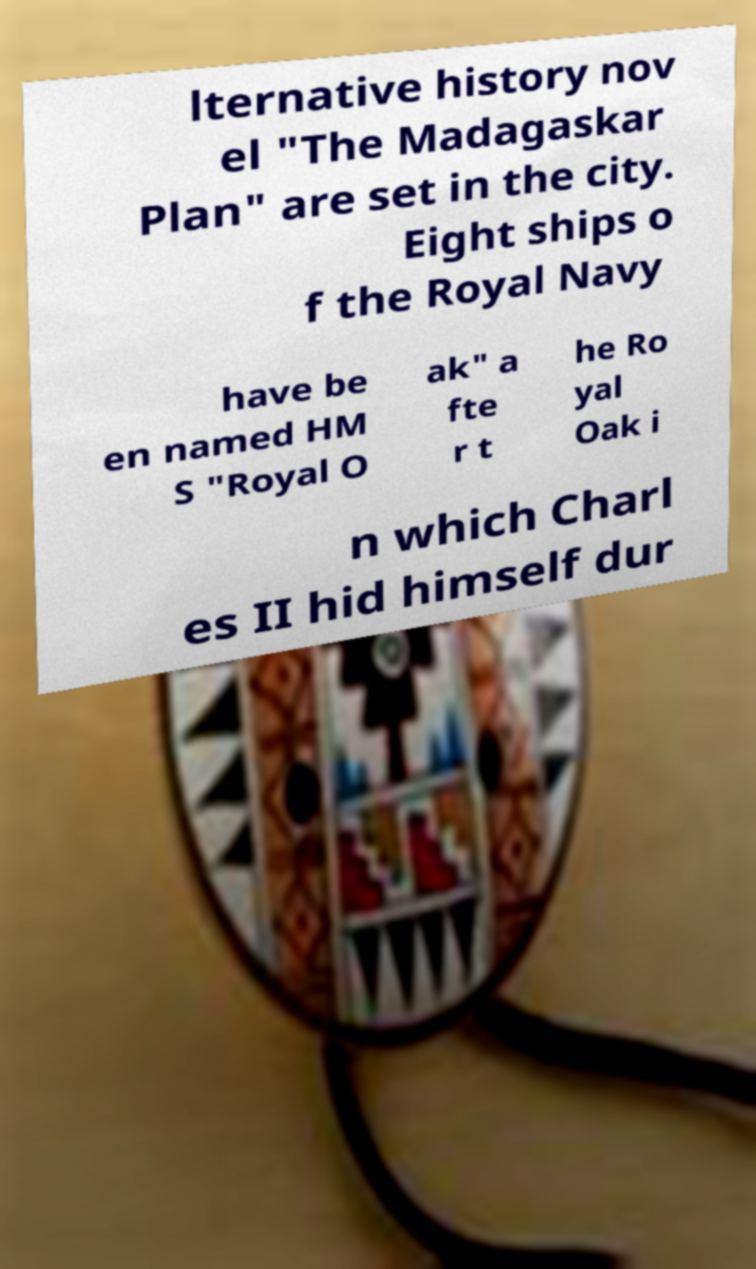Can you accurately transcribe the text from the provided image for me? lternative history nov el "The Madagaskar Plan" are set in the city. Eight ships o f the Royal Navy have be en named HM S "Royal O ak" a fte r t he Ro yal Oak i n which Charl es II hid himself dur 